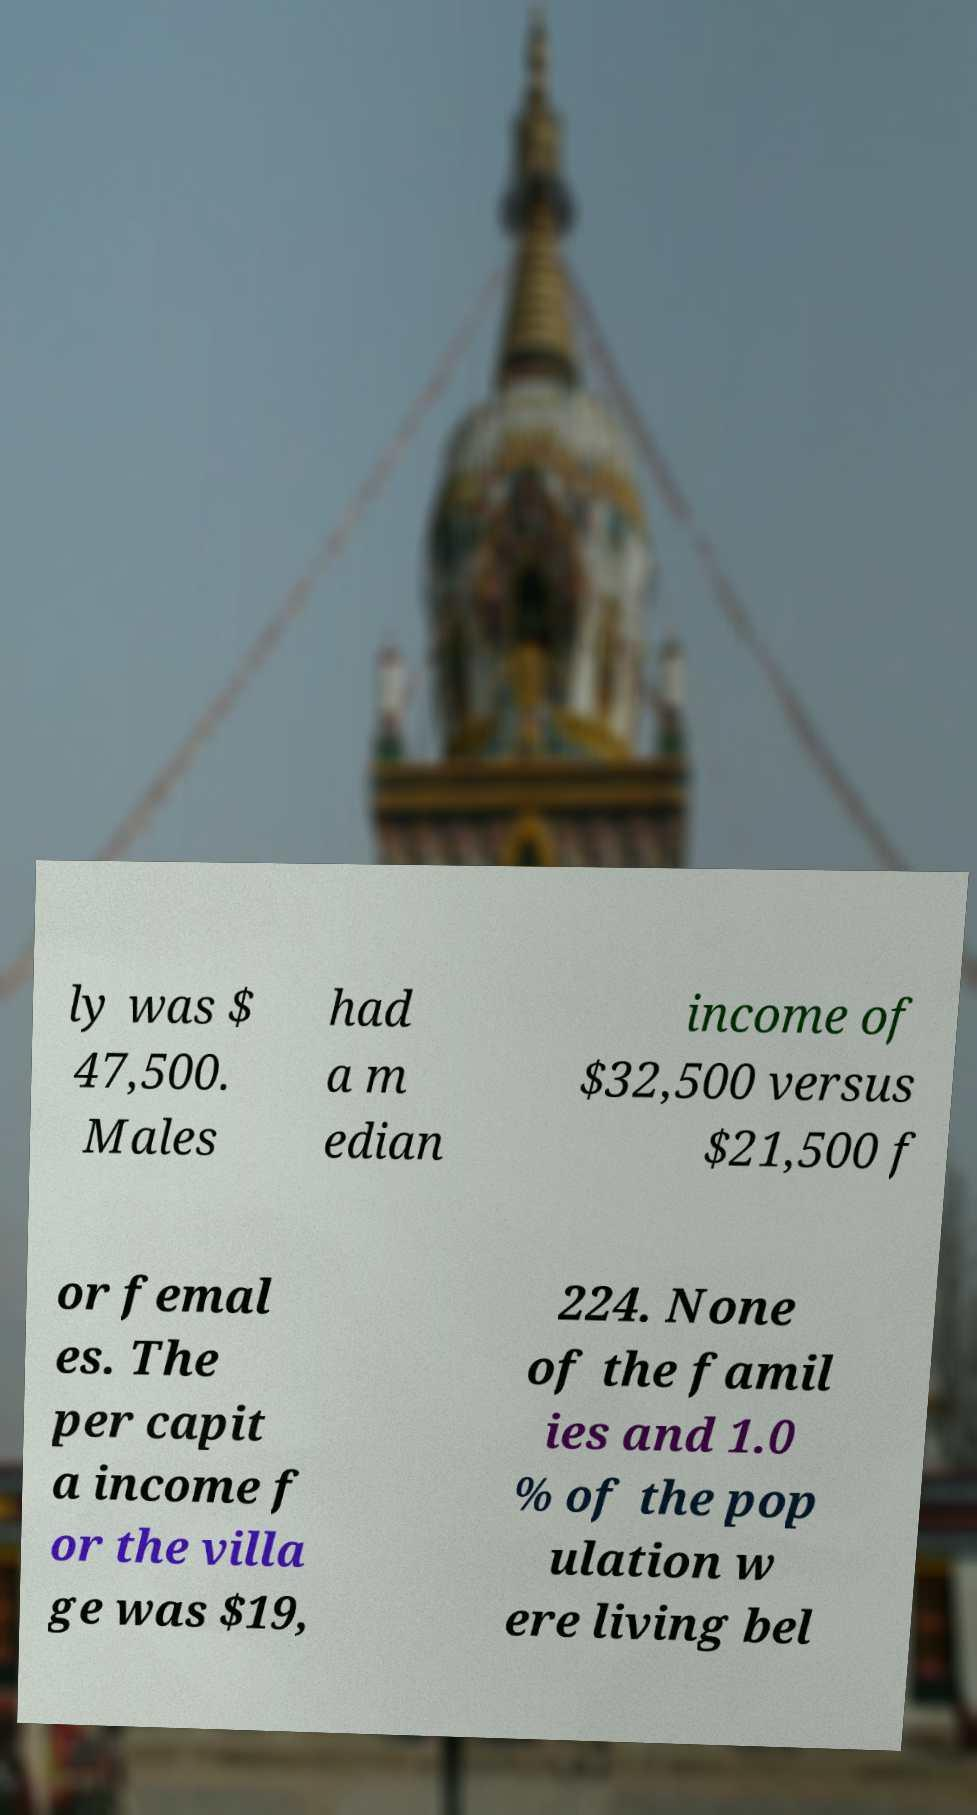Can you accurately transcribe the text from the provided image for me? ly was $ 47,500. Males had a m edian income of $32,500 versus $21,500 f or femal es. The per capit a income f or the villa ge was $19, 224. None of the famil ies and 1.0 % of the pop ulation w ere living bel 